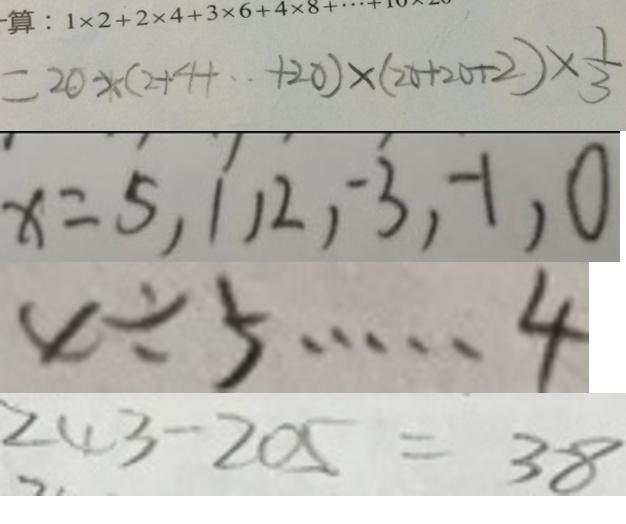<formula> <loc_0><loc_0><loc_500><loc_500>= 2 0 \times ( 2 + 4 + \cdot + 2 0 ) \times ( 2 0 + 2 0 + 2 ) \times \frac { 1 } { 3 } 
 x = 5 , 1 , 2 , - 3 , - 1 , 0 
 x \div 5 \cdots 4 
 2 4 3 - 2 0 5 = 3 8</formula> 